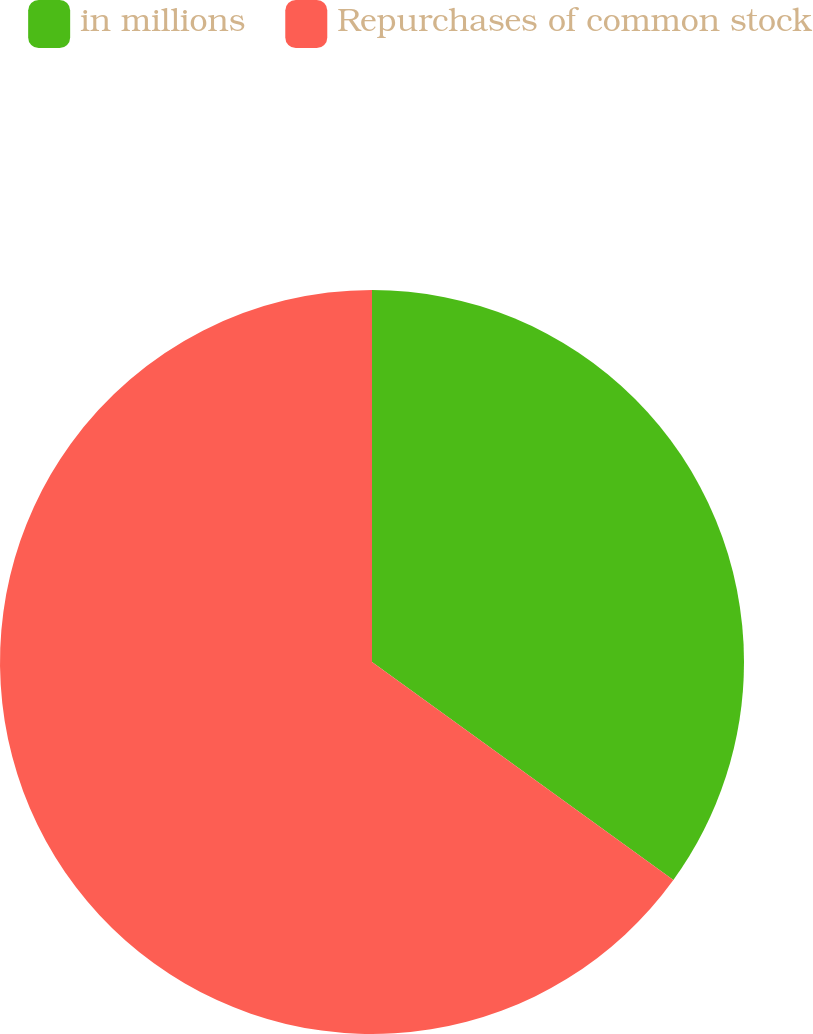<chart> <loc_0><loc_0><loc_500><loc_500><pie_chart><fcel>in millions<fcel>Repurchases of common stock<nl><fcel>34.97%<fcel>65.03%<nl></chart> 